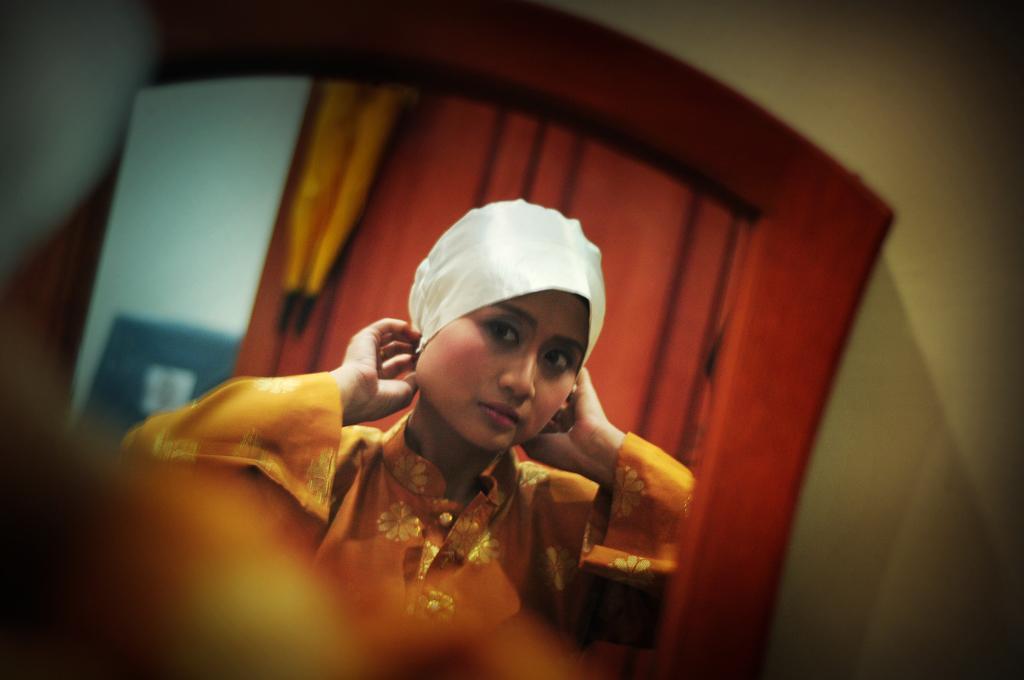Could you give a brief overview of what you see in this image? In this picture there is a mirror in the center of the image, there is a girl in front of a curtain in the mirror. 